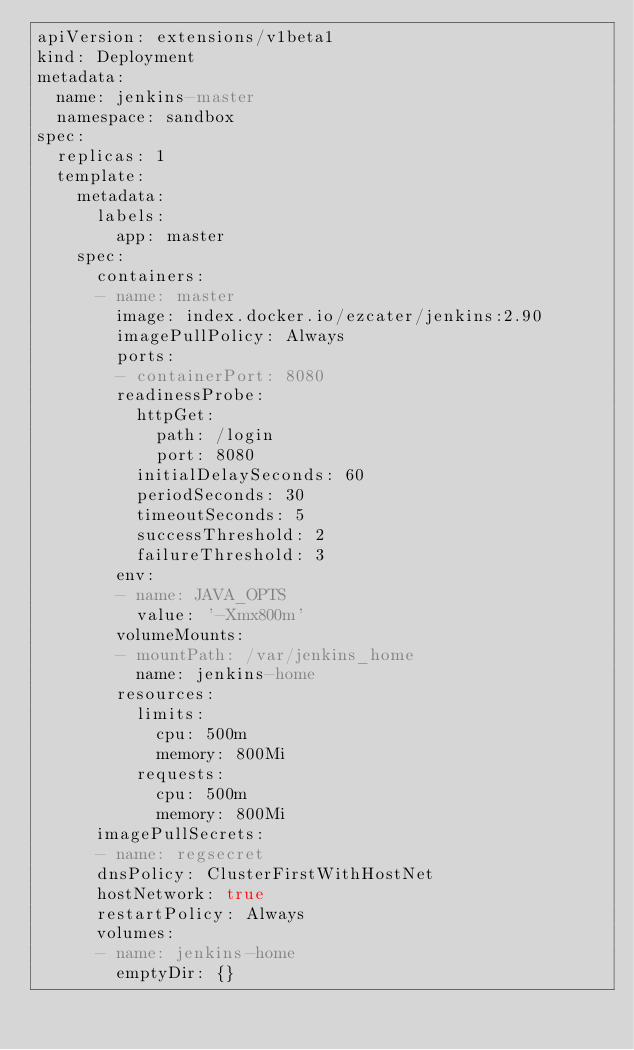Convert code to text. <code><loc_0><loc_0><loc_500><loc_500><_YAML_>apiVersion: extensions/v1beta1
kind: Deployment
metadata:
  name: jenkins-master
  namespace: sandbox
spec:
  replicas: 1
  template:
    metadata:
      labels:
        app: master
    spec:
      containers:
      - name: master
        image: index.docker.io/ezcater/jenkins:2.90
        imagePullPolicy: Always
        ports:
        - containerPort: 8080
        readinessProbe:
          httpGet:
            path: /login
            port: 8080
          initialDelaySeconds: 60
          periodSeconds: 30
          timeoutSeconds: 5
          successThreshold: 2
          failureThreshold: 3
        env:
        - name: JAVA_OPTS
          value: '-Xmx800m'
        volumeMounts:
        - mountPath: /var/jenkins_home
          name: jenkins-home
        resources:
          limits:
            cpu: 500m
            memory: 800Mi
          requests:
            cpu: 500m
            memory: 800Mi
      imagePullSecrets:
      - name: regsecret
      dnsPolicy: ClusterFirstWithHostNet
      hostNetwork: true
      restartPolicy: Always
      volumes:
      - name: jenkins-home
        emptyDir: {}
</code> 